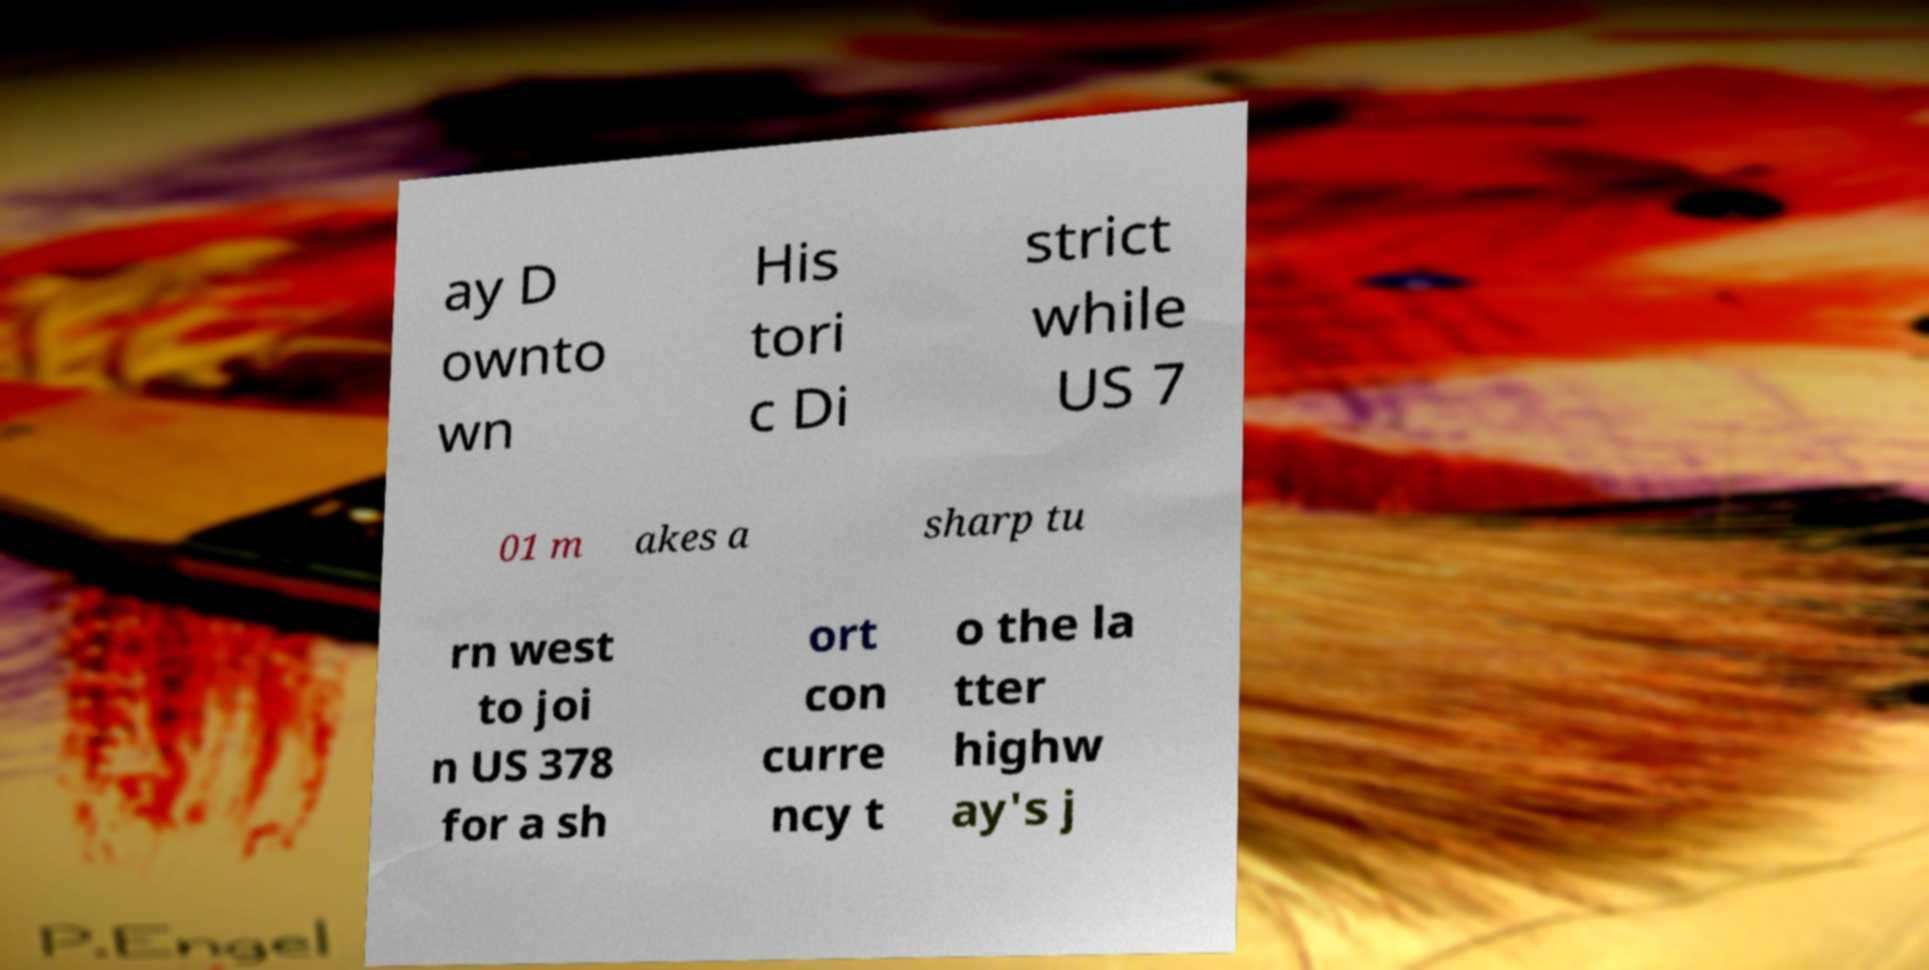For documentation purposes, I need the text within this image transcribed. Could you provide that? ay D ownto wn His tori c Di strict while US 7 01 m akes a sharp tu rn west to joi n US 378 for a sh ort con curre ncy t o the la tter highw ay's j 